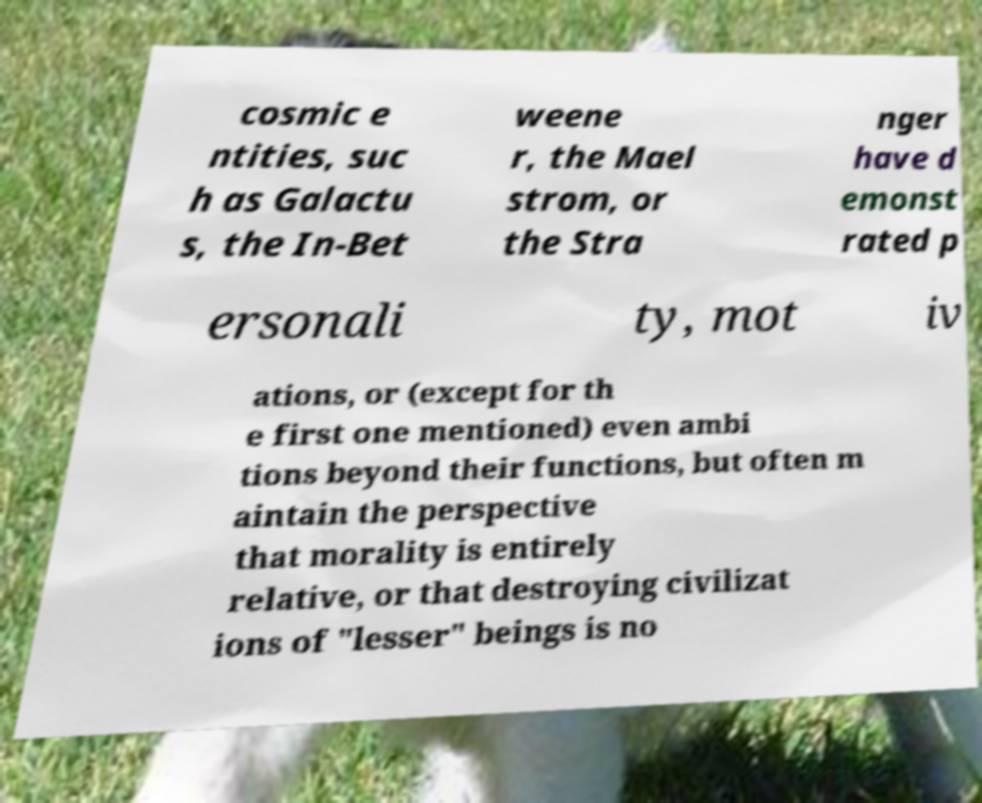I need the written content from this picture converted into text. Can you do that? cosmic e ntities, suc h as Galactu s, the In-Bet weene r, the Mael strom, or the Stra nger have d emonst rated p ersonali ty, mot iv ations, or (except for th e first one mentioned) even ambi tions beyond their functions, but often m aintain the perspective that morality is entirely relative, or that destroying civilizat ions of "lesser" beings is no 